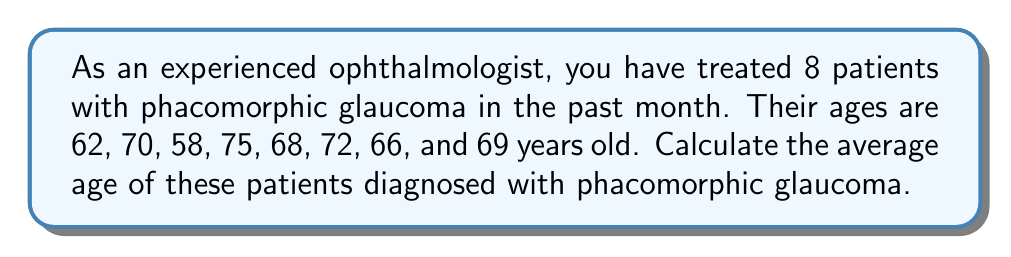Help me with this question. To calculate the average age of the patients, we need to follow these steps:

1. Sum up all the ages:
   $$ 62 + 70 + 58 + 75 + 68 + 72 + 66 + 69 = 540 $$

2. Count the total number of patients:
   There are 8 patients in total.

3. Calculate the average by dividing the sum of ages by the number of patients:
   $$ \text{Average} = \frac{\text{Sum of ages}}{\text{Number of patients}} $$
   $$ \text{Average} = \frac{540}{8} = 67.5 $$

Therefore, the average age of patients diagnosed with phacomorphic glaucoma is 67.5 years old.
Answer: $67.5$ years old 